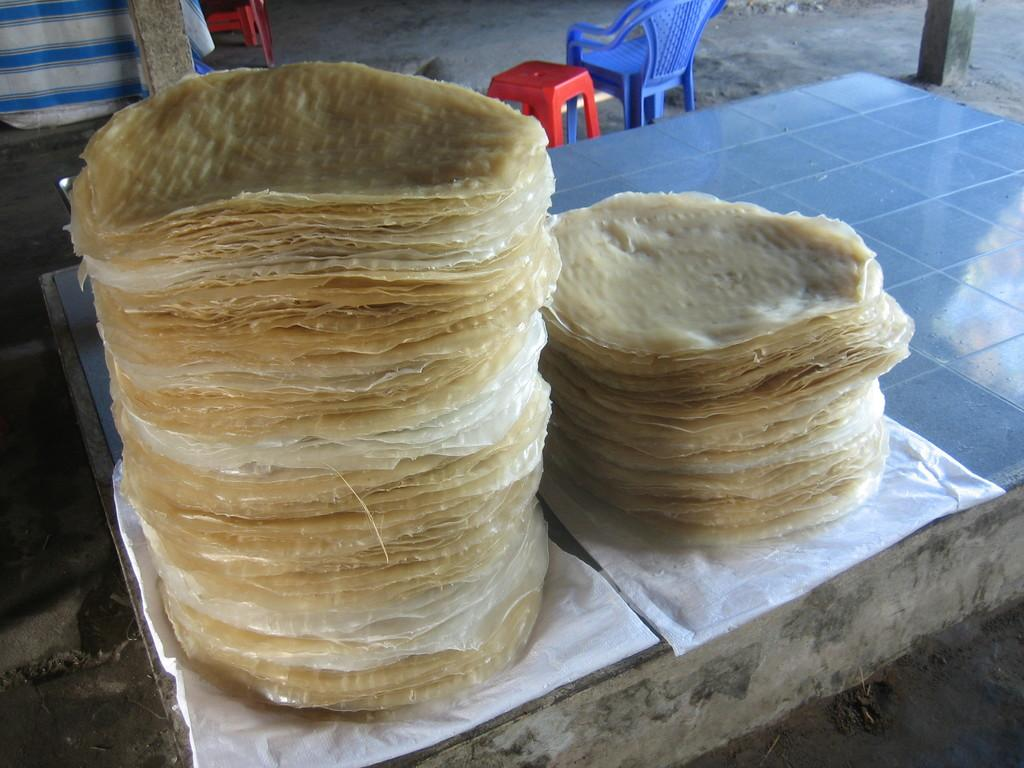What is on the cover that is visible in the image? There is food on a cover in the image. Where is the cover located in the image? The cover is on the floor in the image. What type of furniture can be seen in the image? There are chairs and a stool in the image. What is present in the top left area of the image? A cloth is present in the top left area of the image. What type of engine is visible in the image? There is no engine present in the image. How is the yarn being used in the image? There is no yarn present in the image. 